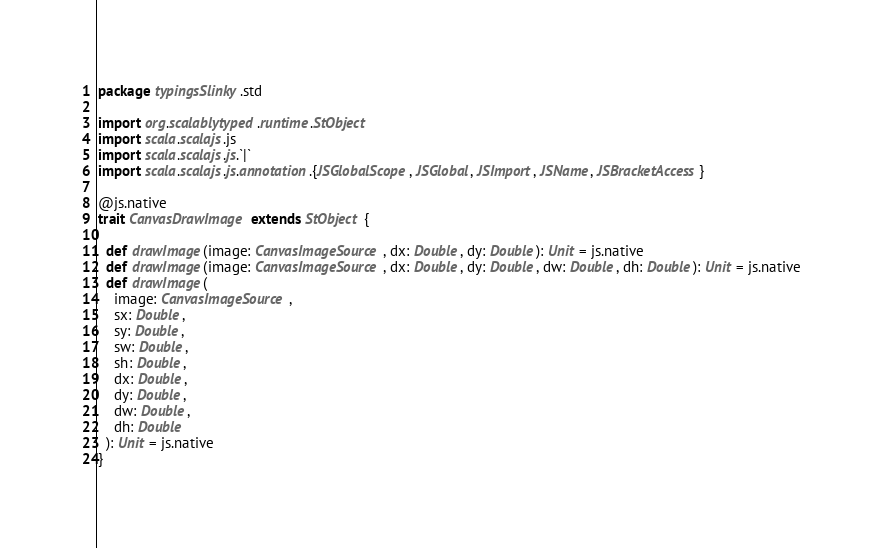<code> <loc_0><loc_0><loc_500><loc_500><_Scala_>package typingsSlinky.std

import org.scalablytyped.runtime.StObject
import scala.scalajs.js
import scala.scalajs.js.`|`
import scala.scalajs.js.annotation.{JSGlobalScope, JSGlobal, JSImport, JSName, JSBracketAccess}

@js.native
trait CanvasDrawImage extends StObject {
  
  def drawImage(image: CanvasImageSource, dx: Double, dy: Double): Unit = js.native
  def drawImage(image: CanvasImageSource, dx: Double, dy: Double, dw: Double, dh: Double): Unit = js.native
  def drawImage(
    image: CanvasImageSource,
    sx: Double,
    sy: Double,
    sw: Double,
    sh: Double,
    dx: Double,
    dy: Double,
    dw: Double,
    dh: Double
  ): Unit = js.native
}
</code> 